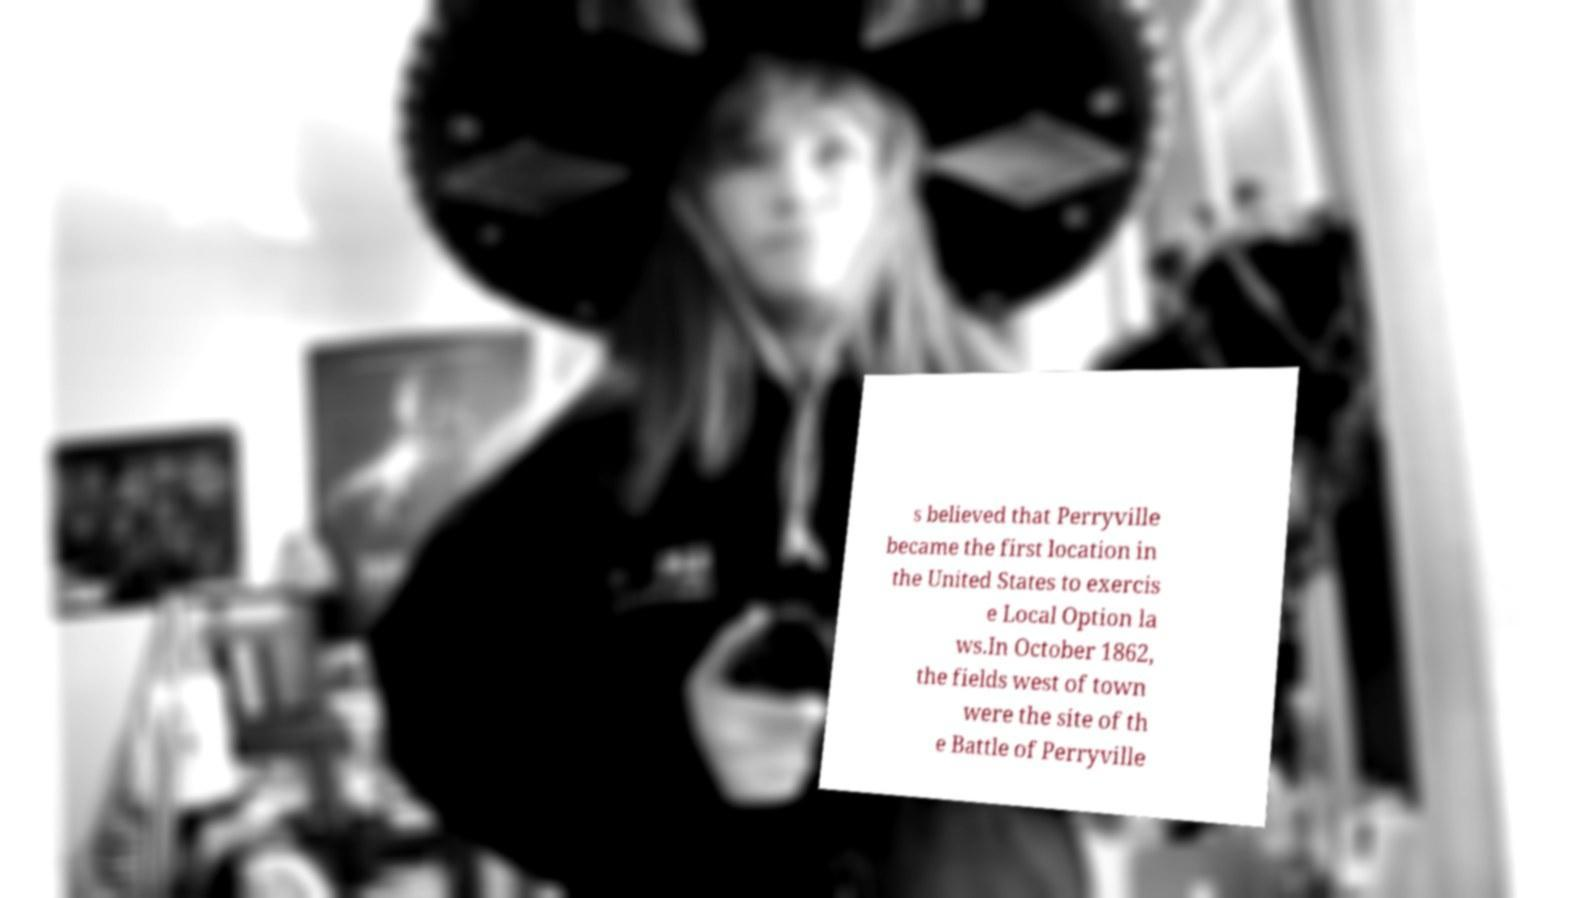Can you accurately transcribe the text from the provided image for me? s believed that Perryville became the first location in the United States to exercis e Local Option la ws.In October 1862, the fields west of town were the site of th e Battle of Perryville 